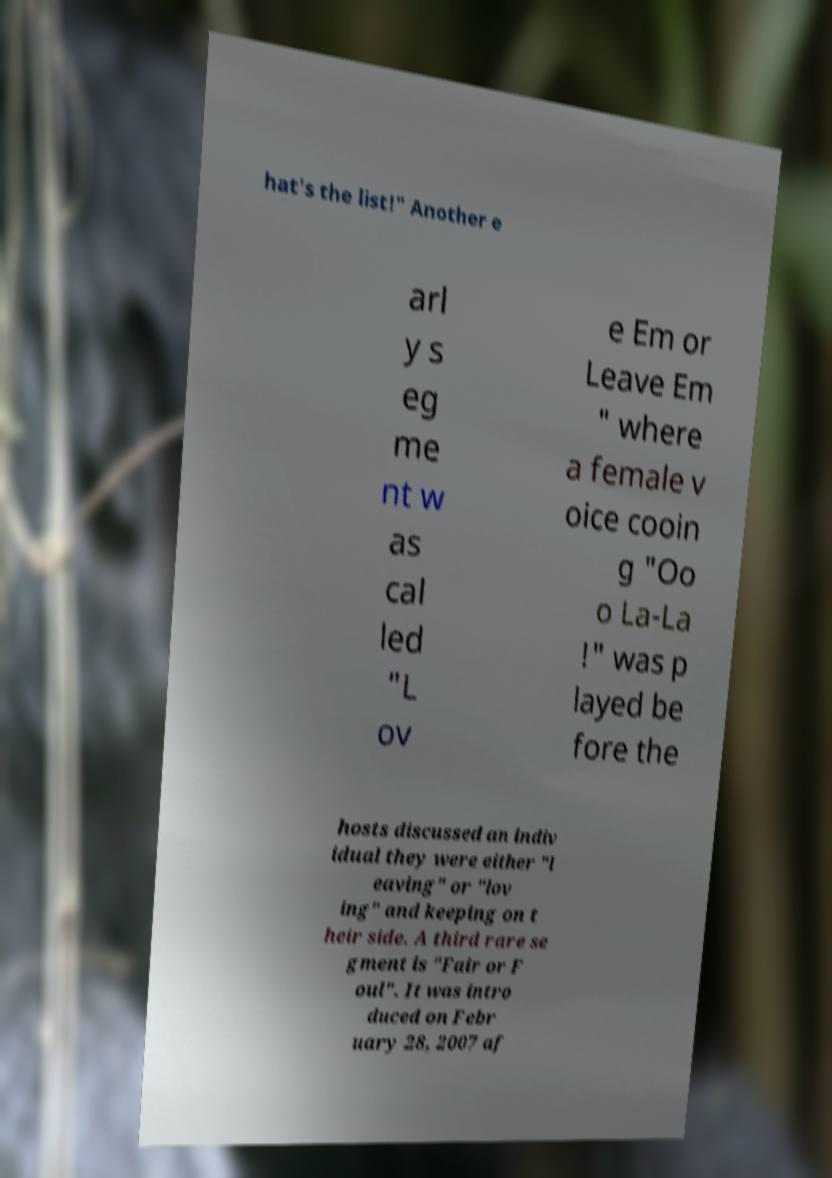Can you accurately transcribe the text from the provided image for me? hat's the list!" Another e arl y s eg me nt w as cal led "L ov e Em or Leave Em " where a female v oice cooin g "Oo o La-La !" was p layed be fore the hosts discussed an indiv idual they were either "l eaving" or "lov ing" and keeping on t heir side. A third rare se gment is "Fair or F oul". It was intro duced on Febr uary 28, 2007 af 